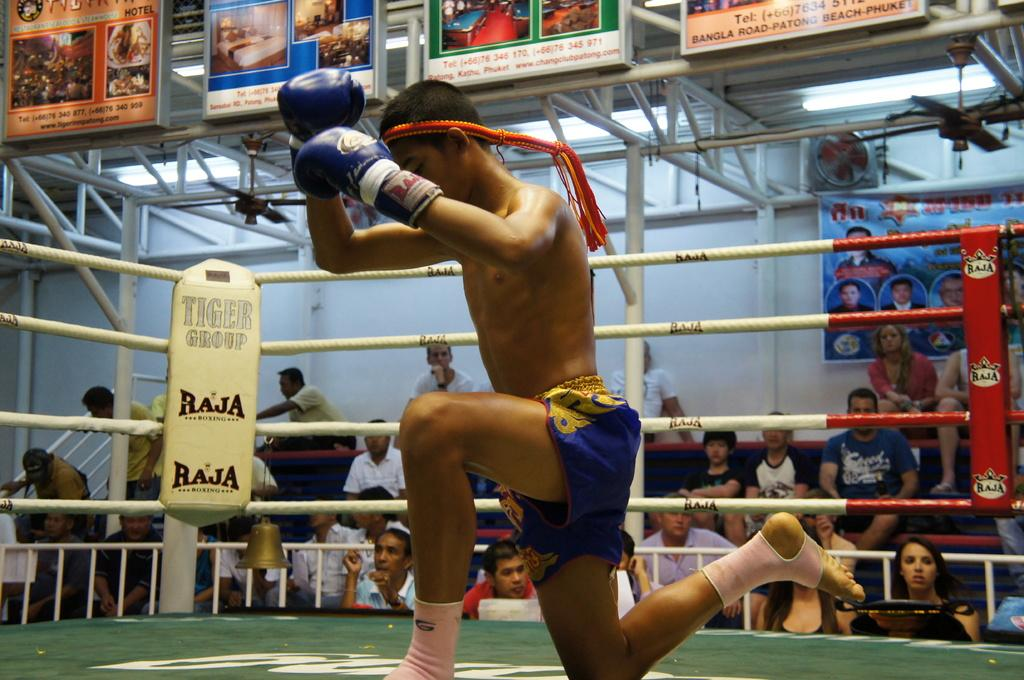<image>
Provide a brief description of the given image. A boxer with blue shorts is kneeling and in the corner of the ring there is a sign that reads " Tiger Group" and "Raja". 